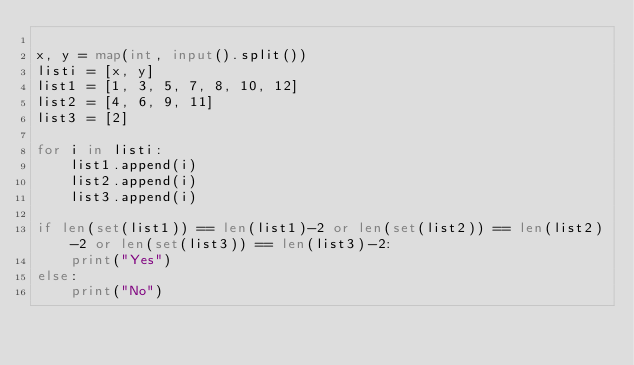Convert code to text. <code><loc_0><loc_0><loc_500><loc_500><_Python_>
x, y = map(int, input().split())
listi = [x, y]
list1 = [1, 3, 5, 7, 8, 10, 12]
list2 = [4, 6, 9, 11]
list3 = [2]

for i in listi:
    list1.append(i)
    list2.append(i)
    list3.append(i)

if len(set(list1)) == len(list1)-2 or len(set(list2)) == len(list2)-2 or len(set(list3)) == len(list3)-2:
    print("Yes")
else:
    print("No")
    </code> 